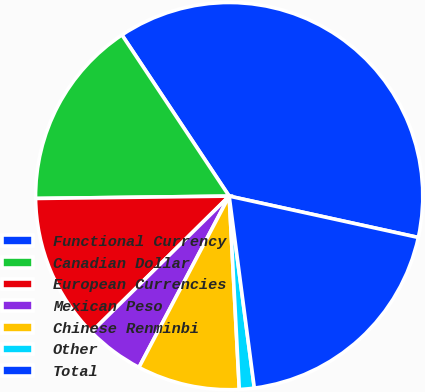<chart> <loc_0><loc_0><loc_500><loc_500><pie_chart><fcel>Functional Currency<fcel>Canadian Dollar<fcel>European Currencies<fcel>Mexican Peso<fcel>Chinese Renminbi<fcel>Other<fcel>Total<nl><fcel>37.77%<fcel>15.85%<fcel>12.2%<fcel>4.89%<fcel>8.55%<fcel>1.24%<fcel>19.5%<nl></chart> 